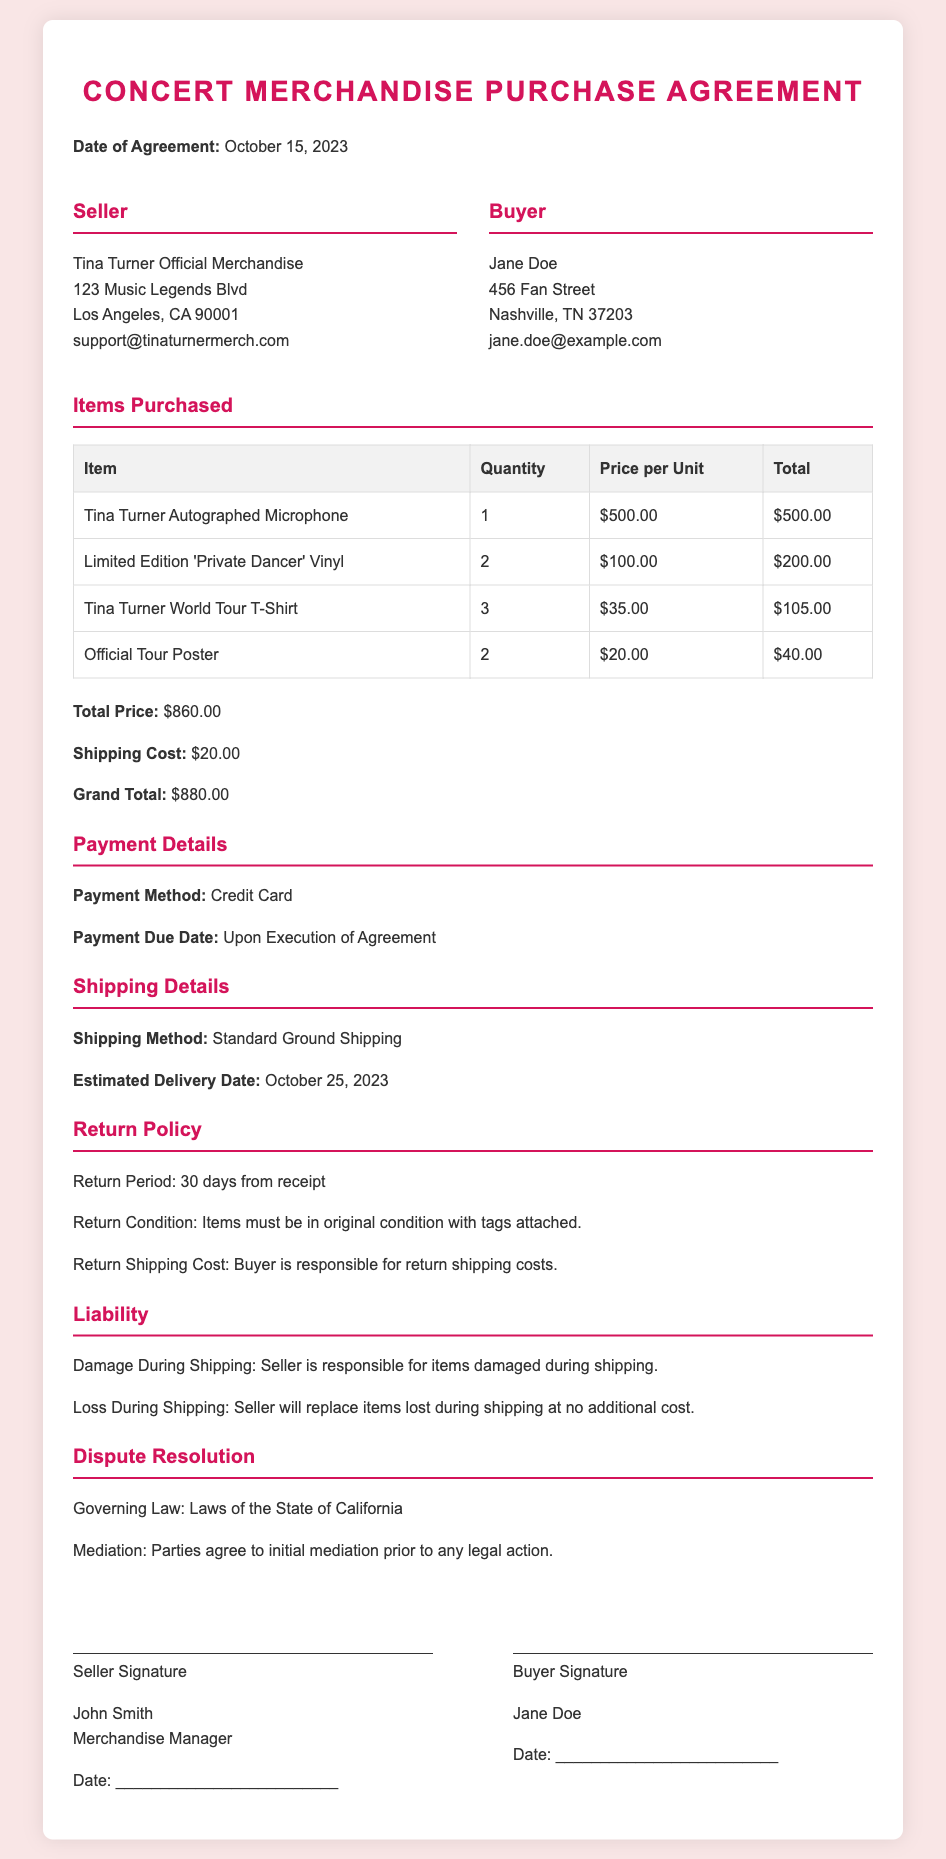What is the date of the agreement? The date of the agreement is explicitly stated in the document as October 15, 2023.
Answer: October 15, 2023 Who is the buyer? The buyer's information is provided in the contract, specifically naming Jane Doe.
Answer: Jane Doe What is the total price of the purchased items? The total price is outlined in the document as $860.00, which sums all item costs before shipping.
Answer: $860.00 What is the estimated delivery date? The document specifies the estimated delivery date for the items as October 25, 2023.
Answer: October 25, 2023 What is the return period? The return policy section specifies that the return period is 30 days from receipt of the items.
Answer: 30 days What is the seller responsible for in the event of damage during shipping? The liability section states that the seller is responsible for items damaged during shipping.
Answer: Seller is responsible How many Tina Turner World Tour T-Shirts were purchased? The quantity of Tina Turner World Tour T-Shirts is listed in the table as 3.
Answer: 3 What shipping method will be used? The document details that the shipping method employed will be Standard Ground Shipping.
Answer: Standard Ground Shipping What is the grand total including shipping? The grand total, given the total price plus shipping cost, is clearly stated as $880.00.
Answer: $880.00 